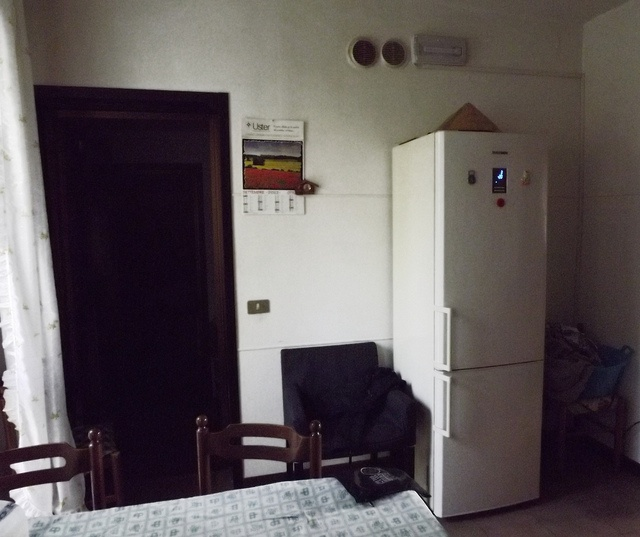Describe the objects in this image and their specific colors. I can see refrigerator in gray, lightgray, and black tones, dining table in gray, darkgray, black, and lightgray tones, chair in black and gray tones, chair in gray, black, and darkgray tones, and chair in black and gray tones in this image. 